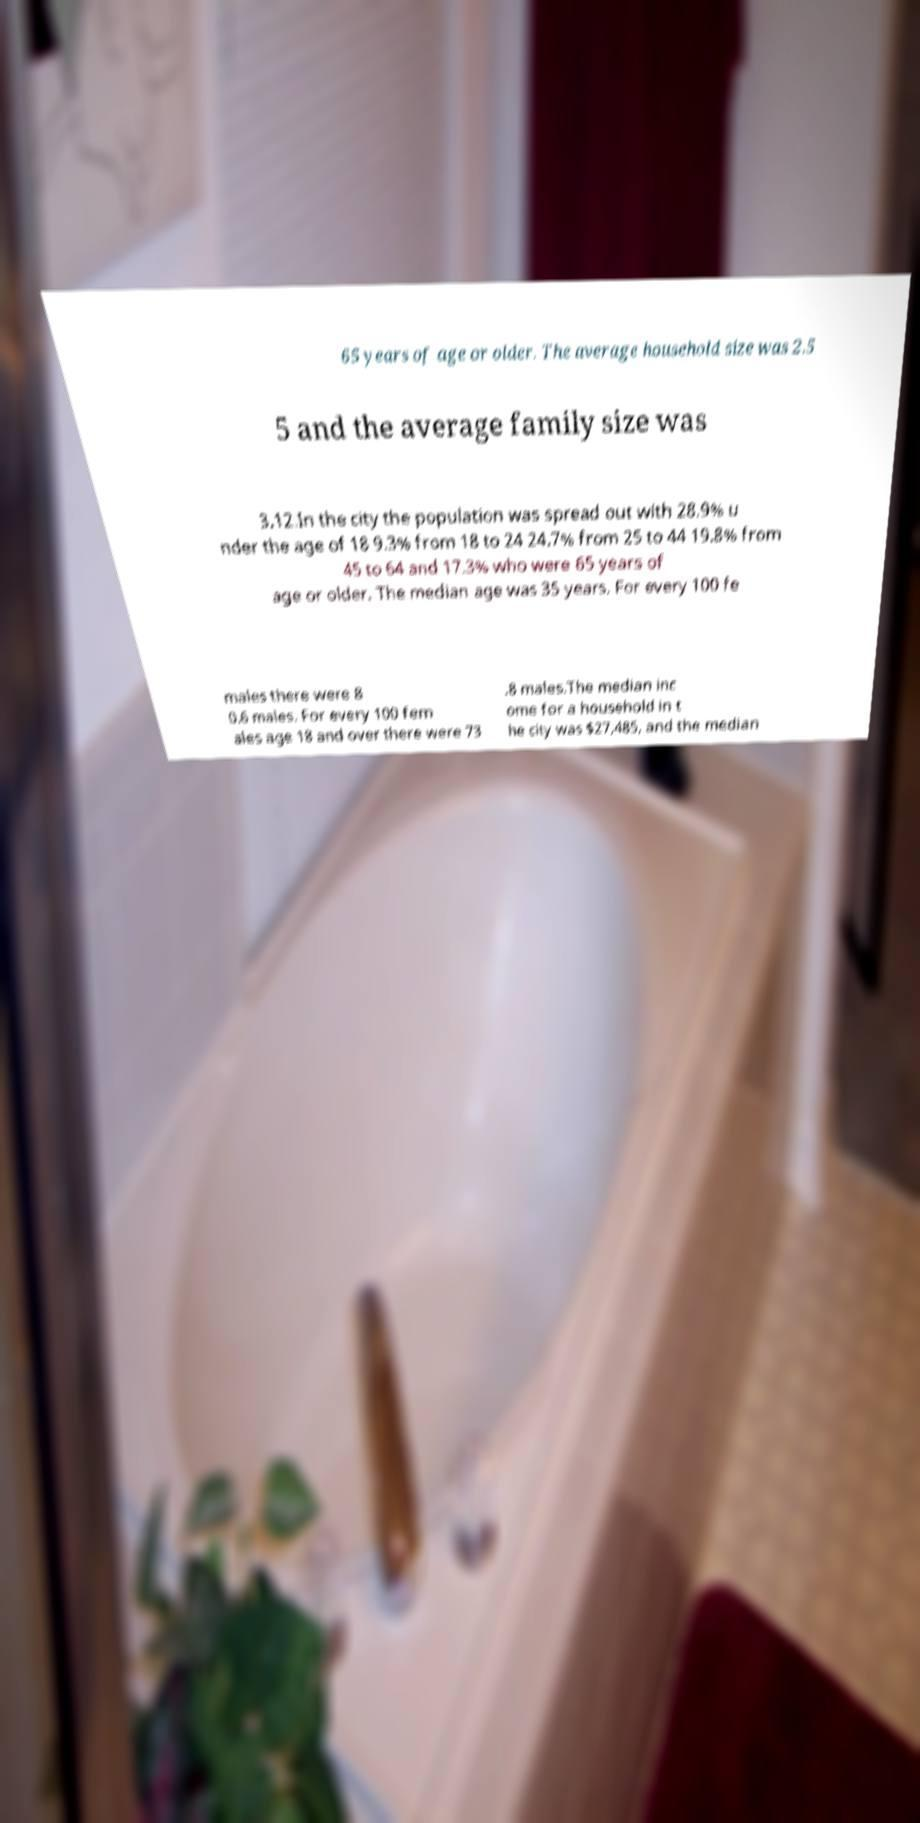Could you assist in decoding the text presented in this image and type it out clearly? 65 years of age or older. The average household size was 2.5 5 and the average family size was 3.12.In the city the population was spread out with 28.9% u nder the age of 18 9.3% from 18 to 24 24.7% from 25 to 44 19.8% from 45 to 64 and 17.3% who were 65 years of age or older. The median age was 35 years. For every 100 fe males there were 8 0.6 males. For every 100 fem ales age 18 and over there were 73 .8 males.The median inc ome for a household in t he city was $27,485, and the median 